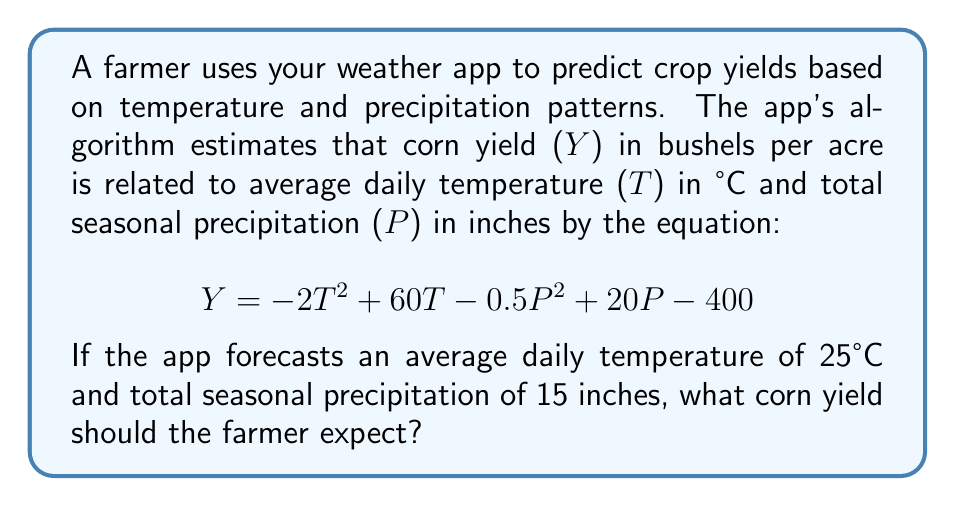Give your solution to this math problem. To solve this problem, we'll follow these steps:

1. Identify the given values:
   $T = 25°C$ (average daily temperature)
   $P = 15$ inches (total seasonal precipitation)

2. Substitute these values into the yield equation:
   $$ Y = -2T^2 + 60T - 0.5P^2 + 20P - 400 $$

3. Calculate each term:
   $-2T^2 = -2(25)^2 = -2(625) = -1250$
   $60T = 60(25) = 1500$
   $-0.5P^2 = -0.5(15)^2 = -0.5(225) = -112.5$
   $20P = 20(15) = 300$
   $-400$ remains as is

4. Sum all the terms:
   $$ Y = -1250 + 1500 - 112.5 + 300 - 400 $$

5. Perform the final calculation:
   $$ Y = 37.5 $$

Therefore, the expected corn yield is 37.5 bushels per acre.
Answer: 37.5 bushels per acre 